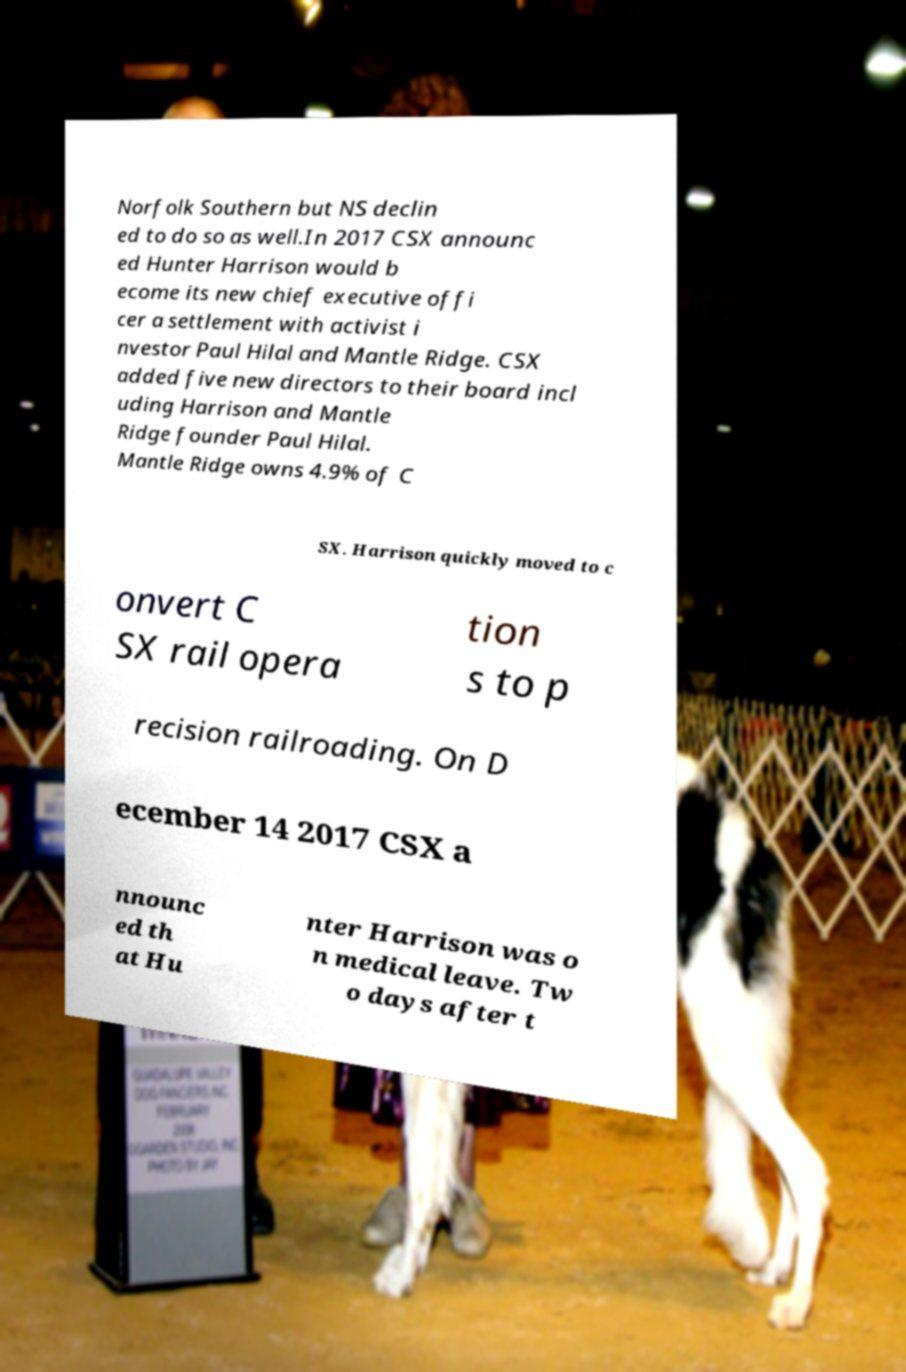Please read and relay the text visible in this image. What does it say? Norfolk Southern but NS declin ed to do so as well.In 2017 CSX announc ed Hunter Harrison would b ecome its new chief executive offi cer a settlement with activist i nvestor Paul Hilal and Mantle Ridge. CSX added five new directors to their board incl uding Harrison and Mantle Ridge founder Paul Hilal. Mantle Ridge owns 4.9% of C SX. Harrison quickly moved to c onvert C SX rail opera tion s to p recision railroading. On D ecember 14 2017 CSX a nnounc ed th at Hu nter Harrison was o n medical leave. Tw o days after t 